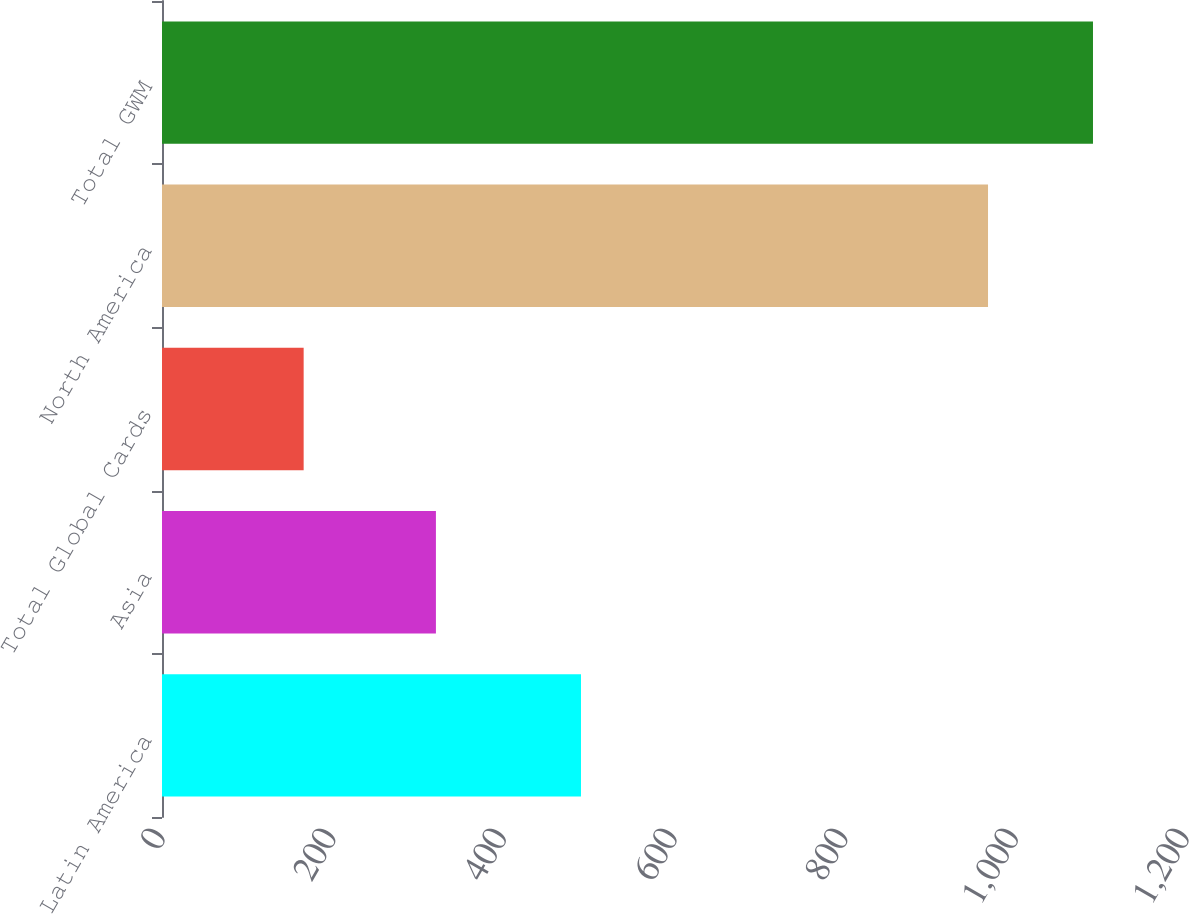Convert chart. <chart><loc_0><loc_0><loc_500><loc_500><bar_chart><fcel>Latin America<fcel>Asia<fcel>Total Global Cards<fcel>North America<fcel>Total GWM<nl><fcel>491<fcel>321<fcel>166<fcel>968<fcel>1091<nl></chart> 